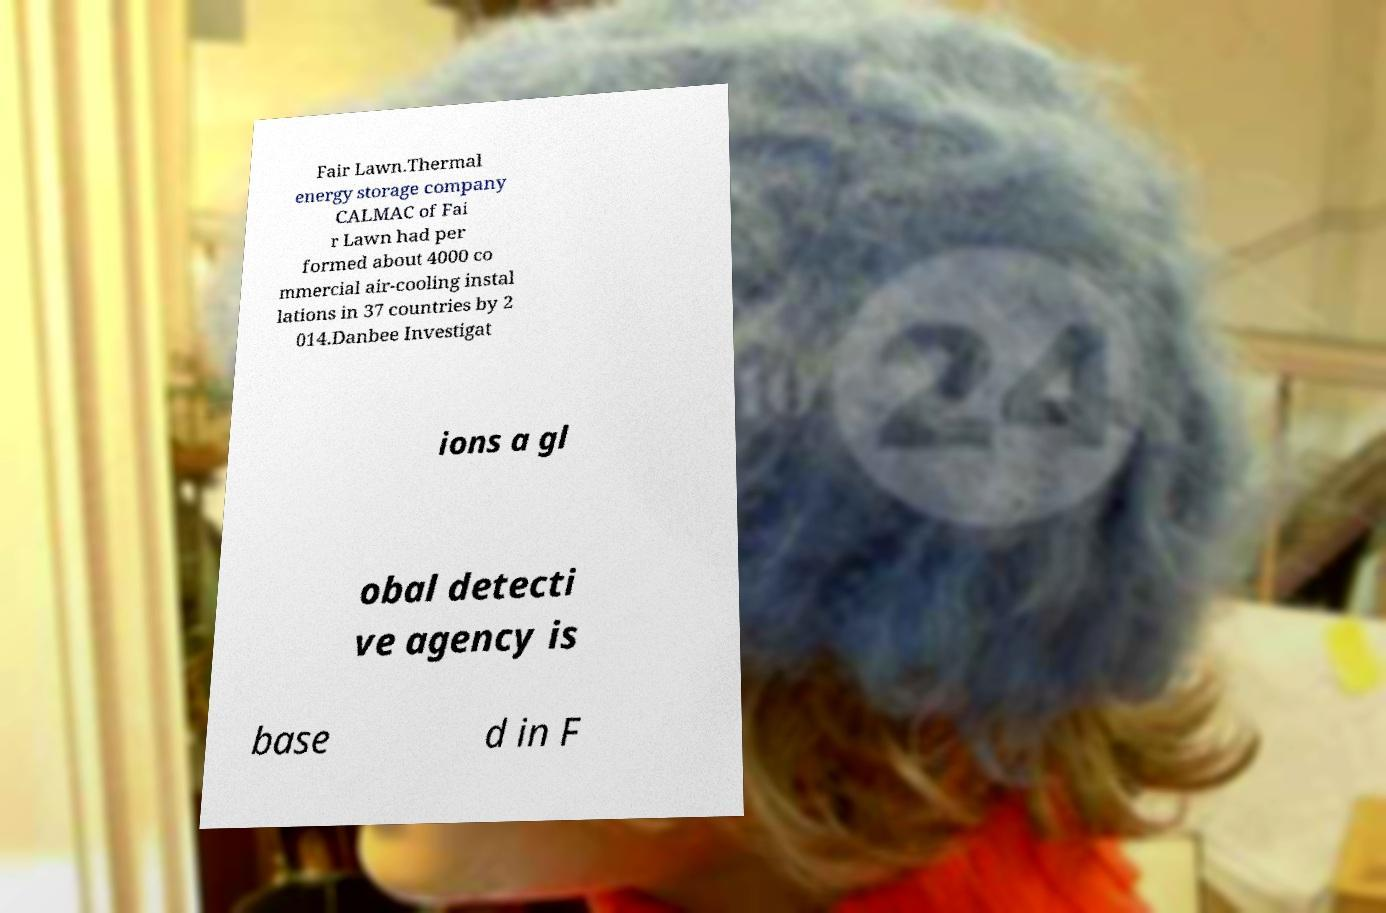I need the written content from this picture converted into text. Can you do that? Fair Lawn.Thermal energy storage company CALMAC of Fai r Lawn had per formed about 4000 co mmercial air-cooling instal lations in 37 countries by 2 014.Danbee Investigat ions a gl obal detecti ve agency is base d in F 